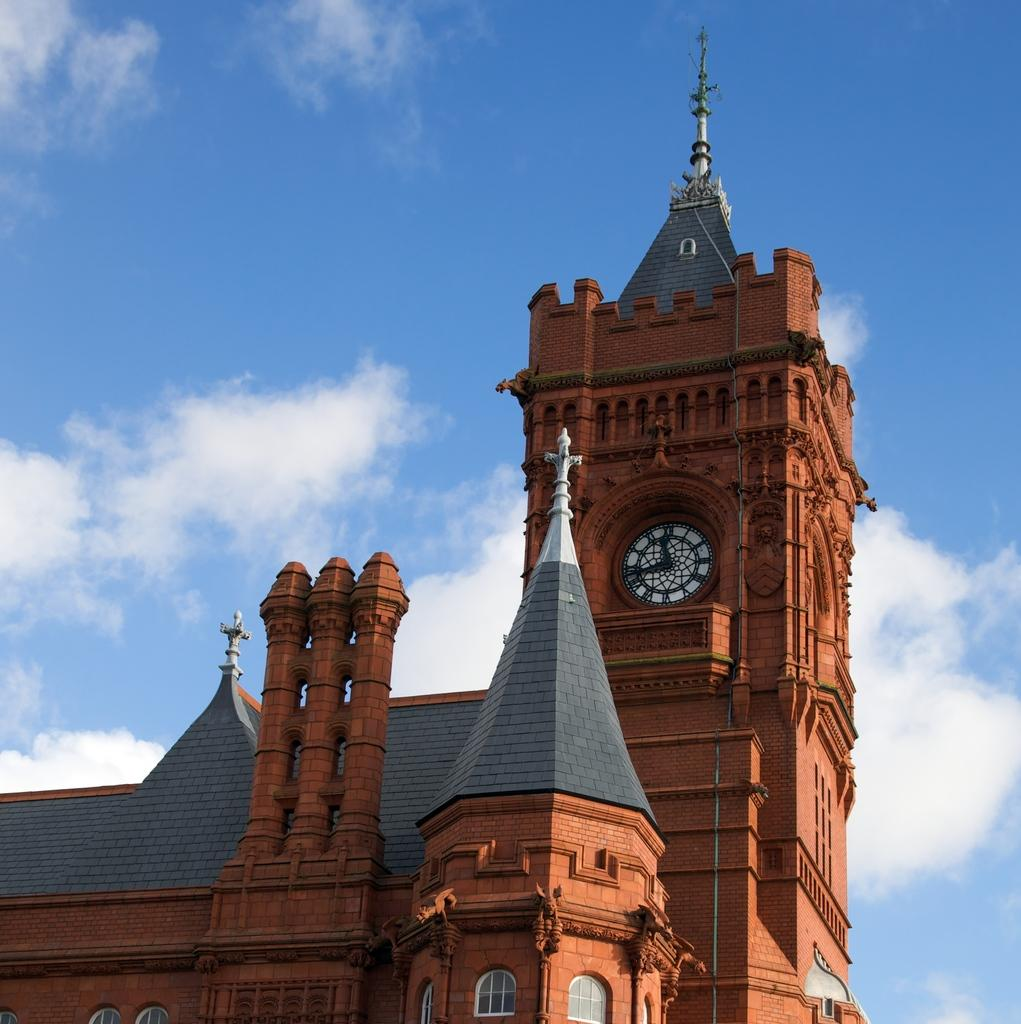What is located on the building in the image? There is a clock on a building in the image. What can be seen in the sky in the background of the image? There are clouds in the sky in the background of the image. Are there any dinosaurs visible in the image? No, there are no dinosaurs present in the image. What type of cart is being used to transport food during the feast in the image? There is no feast or cart present in the image. 